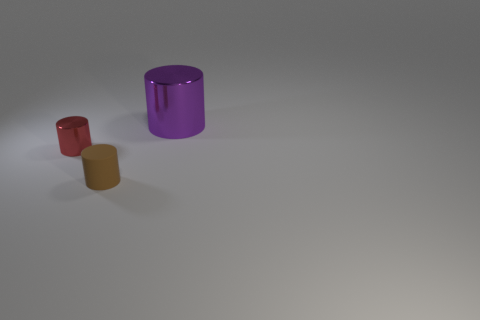Is the material of the tiny object to the left of the rubber object the same as the object to the right of the brown object?
Your answer should be compact. Yes. Is there a red object that has the same size as the purple thing?
Provide a succinct answer. No. There is a metal thing that is on the left side of the object that is on the right side of the small brown cylinder; what is its size?
Provide a succinct answer. Small. What number of tiny matte cylinders have the same color as the big cylinder?
Ensure brevity in your answer.  0. What is the shape of the thing behind the shiny cylinder that is in front of the large purple shiny thing?
Provide a short and direct response. Cylinder. How many brown cylinders are made of the same material as the tiny red cylinder?
Make the answer very short. 0. There is a small cylinder behind the tiny brown rubber object; what is it made of?
Your response must be concise. Metal. What shape is the metal thing on the left side of the small cylinder on the right side of the tiny red metal thing that is on the left side of the brown matte cylinder?
Provide a short and direct response. Cylinder. Are there fewer small metal cylinders that are to the right of the brown rubber thing than big objects that are in front of the red metal cylinder?
Give a very brief answer. No. What color is the other metallic object that is the same shape as the red thing?
Keep it short and to the point. Purple. 